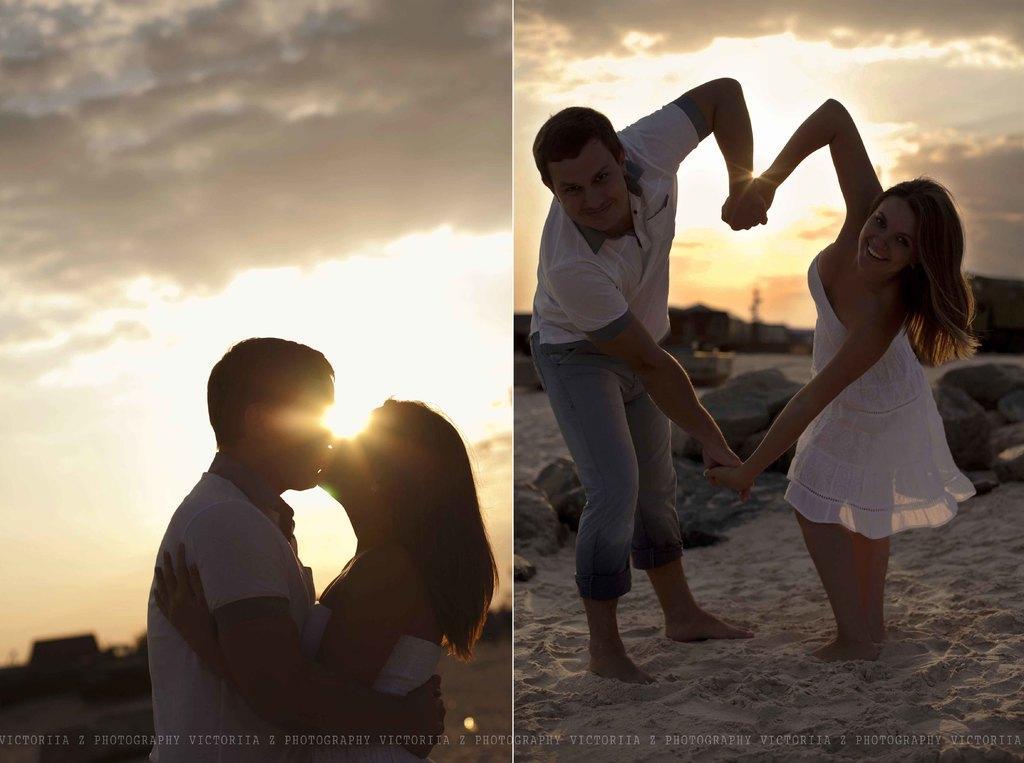Describe this image in one or two sentences. In the image I can see the collage of two pictures in which there is a lady and a guy who are kissing and in the other picture they are holding their hands. 